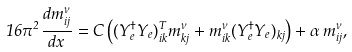Convert formula to latex. <formula><loc_0><loc_0><loc_500><loc_500>1 6 \pi ^ { 2 } \frac { d m ^ { \nu } _ { i j } } { d x } = C \left ( ( Y _ { e } ^ { \dagger } Y _ { e } ) ^ { T } _ { i k } m ^ { \nu } _ { k j } + m ^ { \nu } _ { i k } ( Y _ { e } ^ { \dagger } Y _ { e } ) _ { k j } \right ) + \alpha \, m ^ { \nu } _ { i j } ,</formula> 